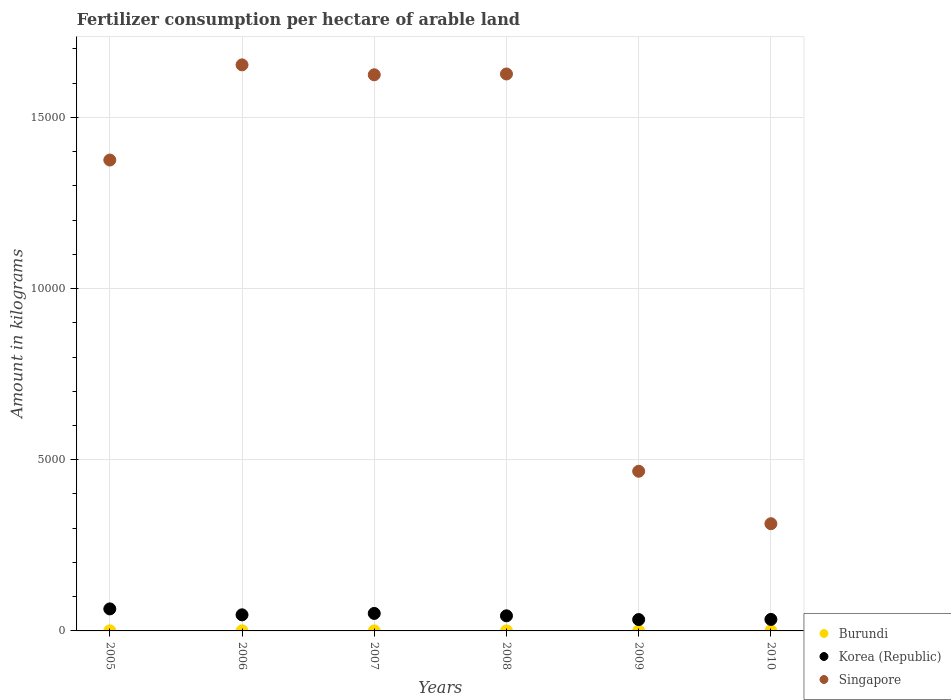What is the amount of fertilizer consumption in Singapore in 2009?
Offer a very short reply. 4663.33. Across all years, what is the maximum amount of fertilizer consumption in Korea (Republic)?
Your answer should be very brief. 643.36. Across all years, what is the minimum amount of fertilizer consumption in Korea (Republic)?
Ensure brevity in your answer.  331.96. In which year was the amount of fertilizer consumption in Korea (Republic) maximum?
Provide a succinct answer. 2005. In which year was the amount of fertilizer consumption in Singapore minimum?
Your answer should be very brief. 2010. What is the total amount of fertilizer consumption in Singapore in the graph?
Your answer should be compact. 7.06e+04. What is the difference between the amount of fertilizer consumption in Korea (Republic) in 2006 and that in 2007?
Make the answer very short. -41.19. What is the difference between the amount of fertilizer consumption in Singapore in 2006 and the amount of fertilizer consumption in Burundi in 2007?
Your answer should be very brief. 1.65e+04. What is the average amount of fertilizer consumption in Korea (Republic) per year?
Make the answer very short. 455.55. In the year 2007, what is the difference between the amount of fertilizer consumption in Burundi and amount of fertilizer consumption in Korea (Republic)?
Ensure brevity in your answer.  -509.02. In how many years, is the amount of fertilizer consumption in Singapore greater than 15000 kg?
Offer a very short reply. 3. What is the ratio of the amount of fertilizer consumption in Burundi in 2009 to that in 2010?
Provide a succinct answer. 0.51. Is the amount of fertilizer consumption in Burundi in 2006 less than that in 2010?
Provide a succinct answer. Yes. Is the difference between the amount of fertilizer consumption in Burundi in 2006 and 2010 greater than the difference between the amount of fertilizer consumption in Korea (Republic) in 2006 and 2010?
Your answer should be compact. No. What is the difference between the highest and the second highest amount of fertilizer consumption in Korea (Republic)?
Offer a terse response. 132.32. What is the difference between the highest and the lowest amount of fertilizer consumption in Burundi?
Ensure brevity in your answer.  1.77. In how many years, is the amount of fertilizer consumption in Korea (Republic) greater than the average amount of fertilizer consumption in Korea (Republic) taken over all years?
Give a very brief answer. 3. Is the sum of the amount of fertilizer consumption in Singapore in 2006 and 2009 greater than the maximum amount of fertilizer consumption in Korea (Republic) across all years?
Provide a succinct answer. Yes. Is it the case that in every year, the sum of the amount of fertilizer consumption in Singapore and amount of fertilizer consumption in Korea (Republic)  is greater than the amount of fertilizer consumption in Burundi?
Provide a short and direct response. Yes. Is the amount of fertilizer consumption in Singapore strictly less than the amount of fertilizer consumption in Burundi over the years?
Your answer should be very brief. No. How many dotlines are there?
Your answer should be very brief. 3. Where does the legend appear in the graph?
Your answer should be very brief. Bottom right. What is the title of the graph?
Keep it short and to the point. Fertilizer consumption per hectare of arable land. What is the label or title of the X-axis?
Offer a very short reply. Years. What is the label or title of the Y-axis?
Offer a very short reply. Amount in kilograms. What is the Amount in kilograms of Burundi in 2005?
Provide a short and direct response. 3.55. What is the Amount in kilograms in Korea (Republic) in 2005?
Provide a succinct answer. 643.36. What is the Amount in kilograms in Singapore in 2005?
Your answer should be compact. 1.38e+04. What is the Amount in kilograms of Burundi in 2006?
Give a very brief answer. 3.34. What is the Amount in kilograms of Korea (Republic) in 2006?
Keep it short and to the point. 469.85. What is the Amount in kilograms in Singapore in 2006?
Your answer should be compact. 1.65e+04. What is the Amount in kilograms of Burundi in 2007?
Your answer should be compact. 2.02. What is the Amount in kilograms of Korea (Republic) in 2007?
Offer a very short reply. 511.04. What is the Amount in kilograms of Singapore in 2007?
Your answer should be very brief. 1.62e+04. What is the Amount in kilograms in Burundi in 2008?
Provide a succinct answer. 2.17. What is the Amount in kilograms of Korea (Republic) in 2008?
Provide a short and direct response. 441.05. What is the Amount in kilograms in Singapore in 2008?
Your response must be concise. 1.63e+04. What is the Amount in kilograms of Burundi in 2009?
Provide a succinct answer. 1.86. What is the Amount in kilograms in Korea (Republic) in 2009?
Your answer should be compact. 331.96. What is the Amount in kilograms in Singapore in 2009?
Offer a very short reply. 4663.33. What is the Amount in kilograms in Burundi in 2010?
Keep it short and to the point. 3.63. What is the Amount in kilograms in Korea (Republic) in 2010?
Make the answer very short. 336.05. What is the Amount in kilograms of Singapore in 2010?
Your answer should be very brief. 3131.25. Across all years, what is the maximum Amount in kilograms of Burundi?
Provide a succinct answer. 3.63. Across all years, what is the maximum Amount in kilograms in Korea (Republic)?
Provide a short and direct response. 643.36. Across all years, what is the maximum Amount in kilograms of Singapore?
Your response must be concise. 1.65e+04. Across all years, what is the minimum Amount in kilograms of Burundi?
Ensure brevity in your answer.  1.86. Across all years, what is the minimum Amount in kilograms in Korea (Republic)?
Provide a succinct answer. 331.96. Across all years, what is the minimum Amount in kilograms of Singapore?
Keep it short and to the point. 3131.25. What is the total Amount in kilograms of Burundi in the graph?
Your answer should be very brief. 16.57. What is the total Amount in kilograms in Korea (Republic) in the graph?
Your response must be concise. 2733.31. What is the total Amount in kilograms of Singapore in the graph?
Keep it short and to the point. 7.06e+04. What is the difference between the Amount in kilograms in Burundi in 2005 and that in 2006?
Your answer should be compact. 0.2. What is the difference between the Amount in kilograms of Korea (Republic) in 2005 and that in 2006?
Provide a short and direct response. 173.51. What is the difference between the Amount in kilograms of Singapore in 2005 and that in 2006?
Your answer should be compact. -2779.28. What is the difference between the Amount in kilograms of Burundi in 2005 and that in 2007?
Your answer should be compact. 1.53. What is the difference between the Amount in kilograms of Korea (Republic) in 2005 and that in 2007?
Your response must be concise. 132.32. What is the difference between the Amount in kilograms of Singapore in 2005 and that in 2007?
Offer a very short reply. -2489.83. What is the difference between the Amount in kilograms of Burundi in 2005 and that in 2008?
Provide a short and direct response. 1.37. What is the difference between the Amount in kilograms in Korea (Republic) in 2005 and that in 2008?
Make the answer very short. 202.31. What is the difference between the Amount in kilograms in Singapore in 2005 and that in 2008?
Your answer should be very brief. -2513.64. What is the difference between the Amount in kilograms in Burundi in 2005 and that in 2009?
Make the answer very short. 1.69. What is the difference between the Amount in kilograms in Korea (Republic) in 2005 and that in 2009?
Give a very brief answer. 311.4. What is the difference between the Amount in kilograms of Singapore in 2005 and that in 2009?
Your response must be concise. 9089.7. What is the difference between the Amount in kilograms of Burundi in 2005 and that in 2010?
Provide a short and direct response. -0.08. What is the difference between the Amount in kilograms in Korea (Republic) in 2005 and that in 2010?
Your answer should be very brief. 307.3. What is the difference between the Amount in kilograms of Singapore in 2005 and that in 2010?
Offer a very short reply. 1.06e+04. What is the difference between the Amount in kilograms in Burundi in 2006 and that in 2007?
Provide a succinct answer. 1.32. What is the difference between the Amount in kilograms in Korea (Republic) in 2006 and that in 2007?
Offer a terse response. -41.19. What is the difference between the Amount in kilograms in Singapore in 2006 and that in 2007?
Keep it short and to the point. 289.45. What is the difference between the Amount in kilograms in Burundi in 2006 and that in 2008?
Offer a terse response. 1.17. What is the difference between the Amount in kilograms in Korea (Republic) in 2006 and that in 2008?
Your response must be concise. 28.8. What is the difference between the Amount in kilograms of Singapore in 2006 and that in 2008?
Provide a short and direct response. 265.64. What is the difference between the Amount in kilograms in Burundi in 2006 and that in 2009?
Ensure brevity in your answer.  1.48. What is the difference between the Amount in kilograms of Korea (Republic) in 2006 and that in 2009?
Provide a short and direct response. 137.89. What is the difference between the Amount in kilograms in Singapore in 2006 and that in 2009?
Make the answer very short. 1.19e+04. What is the difference between the Amount in kilograms in Burundi in 2006 and that in 2010?
Ensure brevity in your answer.  -0.28. What is the difference between the Amount in kilograms in Korea (Republic) in 2006 and that in 2010?
Your answer should be very brief. 133.8. What is the difference between the Amount in kilograms of Singapore in 2006 and that in 2010?
Your answer should be very brief. 1.34e+04. What is the difference between the Amount in kilograms in Burundi in 2007 and that in 2008?
Your answer should be very brief. -0.15. What is the difference between the Amount in kilograms of Korea (Republic) in 2007 and that in 2008?
Offer a very short reply. 69.98. What is the difference between the Amount in kilograms of Singapore in 2007 and that in 2008?
Provide a succinct answer. -23.81. What is the difference between the Amount in kilograms in Burundi in 2007 and that in 2009?
Give a very brief answer. 0.16. What is the difference between the Amount in kilograms of Korea (Republic) in 2007 and that in 2009?
Make the answer very short. 179.08. What is the difference between the Amount in kilograms in Singapore in 2007 and that in 2009?
Your answer should be compact. 1.16e+04. What is the difference between the Amount in kilograms in Burundi in 2007 and that in 2010?
Ensure brevity in your answer.  -1.61. What is the difference between the Amount in kilograms in Korea (Republic) in 2007 and that in 2010?
Your answer should be very brief. 174.98. What is the difference between the Amount in kilograms in Singapore in 2007 and that in 2010?
Provide a short and direct response. 1.31e+04. What is the difference between the Amount in kilograms of Burundi in 2008 and that in 2009?
Give a very brief answer. 0.31. What is the difference between the Amount in kilograms in Korea (Republic) in 2008 and that in 2009?
Offer a terse response. 109.1. What is the difference between the Amount in kilograms in Singapore in 2008 and that in 2009?
Keep it short and to the point. 1.16e+04. What is the difference between the Amount in kilograms of Burundi in 2008 and that in 2010?
Your answer should be very brief. -1.46. What is the difference between the Amount in kilograms in Korea (Republic) in 2008 and that in 2010?
Your answer should be compact. 105. What is the difference between the Amount in kilograms of Singapore in 2008 and that in 2010?
Give a very brief answer. 1.31e+04. What is the difference between the Amount in kilograms in Burundi in 2009 and that in 2010?
Offer a terse response. -1.77. What is the difference between the Amount in kilograms of Korea (Republic) in 2009 and that in 2010?
Make the answer very short. -4.1. What is the difference between the Amount in kilograms in Singapore in 2009 and that in 2010?
Ensure brevity in your answer.  1532.08. What is the difference between the Amount in kilograms in Burundi in 2005 and the Amount in kilograms in Korea (Republic) in 2006?
Offer a very short reply. -466.3. What is the difference between the Amount in kilograms in Burundi in 2005 and the Amount in kilograms in Singapore in 2006?
Offer a terse response. -1.65e+04. What is the difference between the Amount in kilograms in Korea (Republic) in 2005 and the Amount in kilograms in Singapore in 2006?
Your answer should be compact. -1.59e+04. What is the difference between the Amount in kilograms of Burundi in 2005 and the Amount in kilograms of Korea (Republic) in 2007?
Your response must be concise. -507.49. What is the difference between the Amount in kilograms of Burundi in 2005 and the Amount in kilograms of Singapore in 2007?
Your answer should be compact. -1.62e+04. What is the difference between the Amount in kilograms of Korea (Republic) in 2005 and the Amount in kilograms of Singapore in 2007?
Your answer should be compact. -1.56e+04. What is the difference between the Amount in kilograms of Burundi in 2005 and the Amount in kilograms of Korea (Republic) in 2008?
Provide a short and direct response. -437.51. What is the difference between the Amount in kilograms of Burundi in 2005 and the Amount in kilograms of Singapore in 2008?
Provide a succinct answer. -1.63e+04. What is the difference between the Amount in kilograms of Korea (Republic) in 2005 and the Amount in kilograms of Singapore in 2008?
Your answer should be compact. -1.56e+04. What is the difference between the Amount in kilograms in Burundi in 2005 and the Amount in kilograms in Korea (Republic) in 2009?
Provide a short and direct response. -328.41. What is the difference between the Amount in kilograms in Burundi in 2005 and the Amount in kilograms in Singapore in 2009?
Your answer should be very brief. -4659.79. What is the difference between the Amount in kilograms in Korea (Republic) in 2005 and the Amount in kilograms in Singapore in 2009?
Your answer should be compact. -4019.98. What is the difference between the Amount in kilograms in Burundi in 2005 and the Amount in kilograms in Korea (Republic) in 2010?
Your answer should be compact. -332.51. What is the difference between the Amount in kilograms of Burundi in 2005 and the Amount in kilograms of Singapore in 2010?
Keep it short and to the point. -3127.7. What is the difference between the Amount in kilograms in Korea (Republic) in 2005 and the Amount in kilograms in Singapore in 2010?
Offer a very short reply. -2487.89. What is the difference between the Amount in kilograms of Burundi in 2006 and the Amount in kilograms of Korea (Republic) in 2007?
Your answer should be compact. -507.69. What is the difference between the Amount in kilograms in Burundi in 2006 and the Amount in kilograms in Singapore in 2007?
Offer a very short reply. -1.62e+04. What is the difference between the Amount in kilograms of Korea (Republic) in 2006 and the Amount in kilograms of Singapore in 2007?
Your response must be concise. -1.58e+04. What is the difference between the Amount in kilograms in Burundi in 2006 and the Amount in kilograms in Korea (Republic) in 2008?
Your response must be concise. -437.71. What is the difference between the Amount in kilograms in Burundi in 2006 and the Amount in kilograms in Singapore in 2008?
Give a very brief answer. -1.63e+04. What is the difference between the Amount in kilograms of Korea (Republic) in 2006 and the Amount in kilograms of Singapore in 2008?
Your response must be concise. -1.58e+04. What is the difference between the Amount in kilograms of Burundi in 2006 and the Amount in kilograms of Korea (Republic) in 2009?
Provide a short and direct response. -328.61. What is the difference between the Amount in kilograms in Burundi in 2006 and the Amount in kilograms in Singapore in 2009?
Make the answer very short. -4659.99. What is the difference between the Amount in kilograms in Korea (Republic) in 2006 and the Amount in kilograms in Singapore in 2009?
Offer a terse response. -4193.48. What is the difference between the Amount in kilograms in Burundi in 2006 and the Amount in kilograms in Korea (Republic) in 2010?
Keep it short and to the point. -332.71. What is the difference between the Amount in kilograms of Burundi in 2006 and the Amount in kilograms of Singapore in 2010?
Your answer should be very brief. -3127.91. What is the difference between the Amount in kilograms of Korea (Republic) in 2006 and the Amount in kilograms of Singapore in 2010?
Your response must be concise. -2661.4. What is the difference between the Amount in kilograms of Burundi in 2007 and the Amount in kilograms of Korea (Republic) in 2008?
Your answer should be compact. -439.03. What is the difference between the Amount in kilograms of Burundi in 2007 and the Amount in kilograms of Singapore in 2008?
Ensure brevity in your answer.  -1.63e+04. What is the difference between the Amount in kilograms of Korea (Republic) in 2007 and the Amount in kilograms of Singapore in 2008?
Your answer should be very brief. -1.58e+04. What is the difference between the Amount in kilograms in Burundi in 2007 and the Amount in kilograms in Korea (Republic) in 2009?
Your response must be concise. -329.94. What is the difference between the Amount in kilograms of Burundi in 2007 and the Amount in kilograms of Singapore in 2009?
Offer a terse response. -4661.31. What is the difference between the Amount in kilograms of Korea (Republic) in 2007 and the Amount in kilograms of Singapore in 2009?
Give a very brief answer. -4152.3. What is the difference between the Amount in kilograms in Burundi in 2007 and the Amount in kilograms in Korea (Republic) in 2010?
Provide a short and direct response. -334.03. What is the difference between the Amount in kilograms in Burundi in 2007 and the Amount in kilograms in Singapore in 2010?
Your answer should be very brief. -3129.23. What is the difference between the Amount in kilograms in Korea (Republic) in 2007 and the Amount in kilograms in Singapore in 2010?
Offer a very short reply. -2620.21. What is the difference between the Amount in kilograms of Burundi in 2008 and the Amount in kilograms of Korea (Republic) in 2009?
Provide a succinct answer. -329.78. What is the difference between the Amount in kilograms of Burundi in 2008 and the Amount in kilograms of Singapore in 2009?
Provide a succinct answer. -4661.16. What is the difference between the Amount in kilograms in Korea (Republic) in 2008 and the Amount in kilograms in Singapore in 2009?
Provide a succinct answer. -4222.28. What is the difference between the Amount in kilograms of Burundi in 2008 and the Amount in kilograms of Korea (Republic) in 2010?
Ensure brevity in your answer.  -333.88. What is the difference between the Amount in kilograms of Burundi in 2008 and the Amount in kilograms of Singapore in 2010?
Offer a terse response. -3129.08. What is the difference between the Amount in kilograms of Korea (Republic) in 2008 and the Amount in kilograms of Singapore in 2010?
Provide a short and direct response. -2690.2. What is the difference between the Amount in kilograms of Burundi in 2009 and the Amount in kilograms of Korea (Republic) in 2010?
Make the answer very short. -334.19. What is the difference between the Amount in kilograms in Burundi in 2009 and the Amount in kilograms in Singapore in 2010?
Make the answer very short. -3129.39. What is the difference between the Amount in kilograms of Korea (Republic) in 2009 and the Amount in kilograms of Singapore in 2010?
Offer a terse response. -2799.29. What is the average Amount in kilograms of Burundi per year?
Provide a succinct answer. 2.76. What is the average Amount in kilograms of Korea (Republic) per year?
Provide a succinct answer. 455.55. What is the average Amount in kilograms in Singapore per year?
Offer a very short reply. 1.18e+04. In the year 2005, what is the difference between the Amount in kilograms of Burundi and Amount in kilograms of Korea (Republic)?
Ensure brevity in your answer.  -639.81. In the year 2005, what is the difference between the Amount in kilograms in Burundi and Amount in kilograms in Singapore?
Provide a succinct answer. -1.37e+04. In the year 2005, what is the difference between the Amount in kilograms of Korea (Republic) and Amount in kilograms of Singapore?
Provide a short and direct response. -1.31e+04. In the year 2006, what is the difference between the Amount in kilograms in Burundi and Amount in kilograms in Korea (Republic)?
Your response must be concise. -466.51. In the year 2006, what is the difference between the Amount in kilograms of Burundi and Amount in kilograms of Singapore?
Offer a terse response. -1.65e+04. In the year 2006, what is the difference between the Amount in kilograms of Korea (Republic) and Amount in kilograms of Singapore?
Your answer should be very brief. -1.61e+04. In the year 2007, what is the difference between the Amount in kilograms in Burundi and Amount in kilograms in Korea (Republic)?
Keep it short and to the point. -509.02. In the year 2007, what is the difference between the Amount in kilograms in Burundi and Amount in kilograms in Singapore?
Your response must be concise. -1.62e+04. In the year 2007, what is the difference between the Amount in kilograms in Korea (Republic) and Amount in kilograms in Singapore?
Give a very brief answer. -1.57e+04. In the year 2008, what is the difference between the Amount in kilograms of Burundi and Amount in kilograms of Korea (Republic)?
Give a very brief answer. -438.88. In the year 2008, what is the difference between the Amount in kilograms in Burundi and Amount in kilograms in Singapore?
Your answer should be compact. -1.63e+04. In the year 2008, what is the difference between the Amount in kilograms of Korea (Republic) and Amount in kilograms of Singapore?
Your answer should be very brief. -1.58e+04. In the year 2009, what is the difference between the Amount in kilograms in Burundi and Amount in kilograms in Korea (Republic)?
Your response must be concise. -330.09. In the year 2009, what is the difference between the Amount in kilograms in Burundi and Amount in kilograms in Singapore?
Offer a terse response. -4661.47. In the year 2009, what is the difference between the Amount in kilograms of Korea (Republic) and Amount in kilograms of Singapore?
Offer a terse response. -4331.38. In the year 2010, what is the difference between the Amount in kilograms of Burundi and Amount in kilograms of Korea (Republic)?
Your answer should be very brief. -332.43. In the year 2010, what is the difference between the Amount in kilograms of Burundi and Amount in kilograms of Singapore?
Ensure brevity in your answer.  -3127.62. In the year 2010, what is the difference between the Amount in kilograms of Korea (Republic) and Amount in kilograms of Singapore?
Your answer should be compact. -2795.2. What is the ratio of the Amount in kilograms in Burundi in 2005 to that in 2006?
Offer a terse response. 1.06. What is the ratio of the Amount in kilograms of Korea (Republic) in 2005 to that in 2006?
Your answer should be compact. 1.37. What is the ratio of the Amount in kilograms of Singapore in 2005 to that in 2006?
Your response must be concise. 0.83. What is the ratio of the Amount in kilograms of Burundi in 2005 to that in 2007?
Your response must be concise. 1.76. What is the ratio of the Amount in kilograms in Korea (Republic) in 2005 to that in 2007?
Your answer should be compact. 1.26. What is the ratio of the Amount in kilograms in Singapore in 2005 to that in 2007?
Make the answer very short. 0.85. What is the ratio of the Amount in kilograms in Burundi in 2005 to that in 2008?
Your response must be concise. 1.63. What is the ratio of the Amount in kilograms in Korea (Republic) in 2005 to that in 2008?
Ensure brevity in your answer.  1.46. What is the ratio of the Amount in kilograms in Singapore in 2005 to that in 2008?
Your answer should be very brief. 0.85. What is the ratio of the Amount in kilograms in Burundi in 2005 to that in 2009?
Your answer should be very brief. 1.91. What is the ratio of the Amount in kilograms in Korea (Republic) in 2005 to that in 2009?
Make the answer very short. 1.94. What is the ratio of the Amount in kilograms in Singapore in 2005 to that in 2009?
Give a very brief answer. 2.95. What is the ratio of the Amount in kilograms of Burundi in 2005 to that in 2010?
Your response must be concise. 0.98. What is the ratio of the Amount in kilograms in Korea (Republic) in 2005 to that in 2010?
Keep it short and to the point. 1.91. What is the ratio of the Amount in kilograms of Singapore in 2005 to that in 2010?
Provide a short and direct response. 4.39. What is the ratio of the Amount in kilograms in Burundi in 2006 to that in 2007?
Your response must be concise. 1.66. What is the ratio of the Amount in kilograms in Korea (Republic) in 2006 to that in 2007?
Offer a very short reply. 0.92. What is the ratio of the Amount in kilograms of Singapore in 2006 to that in 2007?
Give a very brief answer. 1.02. What is the ratio of the Amount in kilograms of Burundi in 2006 to that in 2008?
Your response must be concise. 1.54. What is the ratio of the Amount in kilograms of Korea (Republic) in 2006 to that in 2008?
Give a very brief answer. 1.07. What is the ratio of the Amount in kilograms in Singapore in 2006 to that in 2008?
Provide a short and direct response. 1.02. What is the ratio of the Amount in kilograms of Burundi in 2006 to that in 2009?
Give a very brief answer. 1.8. What is the ratio of the Amount in kilograms in Korea (Republic) in 2006 to that in 2009?
Offer a terse response. 1.42. What is the ratio of the Amount in kilograms in Singapore in 2006 to that in 2009?
Keep it short and to the point. 3.55. What is the ratio of the Amount in kilograms in Burundi in 2006 to that in 2010?
Offer a terse response. 0.92. What is the ratio of the Amount in kilograms of Korea (Republic) in 2006 to that in 2010?
Your answer should be compact. 1.4. What is the ratio of the Amount in kilograms in Singapore in 2006 to that in 2010?
Your response must be concise. 5.28. What is the ratio of the Amount in kilograms in Burundi in 2007 to that in 2008?
Give a very brief answer. 0.93. What is the ratio of the Amount in kilograms of Korea (Republic) in 2007 to that in 2008?
Your answer should be very brief. 1.16. What is the ratio of the Amount in kilograms in Singapore in 2007 to that in 2008?
Keep it short and to the point. 1. What is the ratio of the Amount in kilograms of Burundi in 2007 to that in 2009?
Provide a succinct answer. 1.08. What is the ratio of the Amount in kilograms in Korea (Republic) in 2007 to that in 2009?
Your answer should be compact. 1.54. What is the ratio of the Amount in kilograms of Singapore in 2007 to that in 2009?
Keep it short and to the point. 3.48. What is the ratio of the Amount in kilograms of Burundi in 2007 to that in 2010?
Your response must be concise. 0.56. What is the ratio of the Amount in kilograms of Korea (Republic) in 2007 to that in 2010?
Your answer should be compact. 1.52. What is the ratio of the Amount in kilograms in Singapore in 2007 to that in 2010?
Provide a short and direct response. 5.19. What is the ratio of the Amount in kilograms in Burundi in 2008 to that in 2009?
Provide a short and direct response. 1.17. What is the ratio of the Amount in kilograms in Korea (Republic) in 2008 to that in 2009?
Provide a short and direct response. 1.33. What is the ratio of the Amount in kilograms of Singapore in 2008 to that in 2009?
Your response must be concise. 3.49. What is the ratio of the Amount in kilograms in Burundi in 2008 to that in 2010?
Your response must be concise. 0.6. What is the ratio of the Amount in kilograms of Korea (Republic) in 2008 to that in 2010?
Give a very brief answer. 1.31. What is the ratio of the Amount in kilograms in Singapore in 2008 to that in 2010?
Keep it short and to the point. 5.19. What is the ratio of the Amount in kilograms in Burundi in 2009 to that in 2010?
Provide a short and direct response. 0.51. What is the ratio of the Amount in kilograms of Singapore in 2009 to that in 2010?
Offer a terse response. 1.49. What is the difference between the highest and the second highest Amount in kilograms of Burundi?
Keep it short and to the point. 0.08. What is the difference between the highest and the second highest Amount in kilograms of Korea (Republic)?
Ensure brevity in your answer.  132.32. What is the difference between the highest and the second highest Amount in kilograms in Singapore?
Keep it short and to the point. 265.64. What is the difference between the highest and the lowest Amount in kilograms of Burundi?
Ensure brevity in your answer.  1.77. What is the difference between the highest and the lowest Amount in kilograms in Korea (Republic)?
Give a very brief answer. 311.4. What is the difference between the highest and the lowest Amount in kilograms of Singapore?
Offer a terse response. 1.34e+04. 